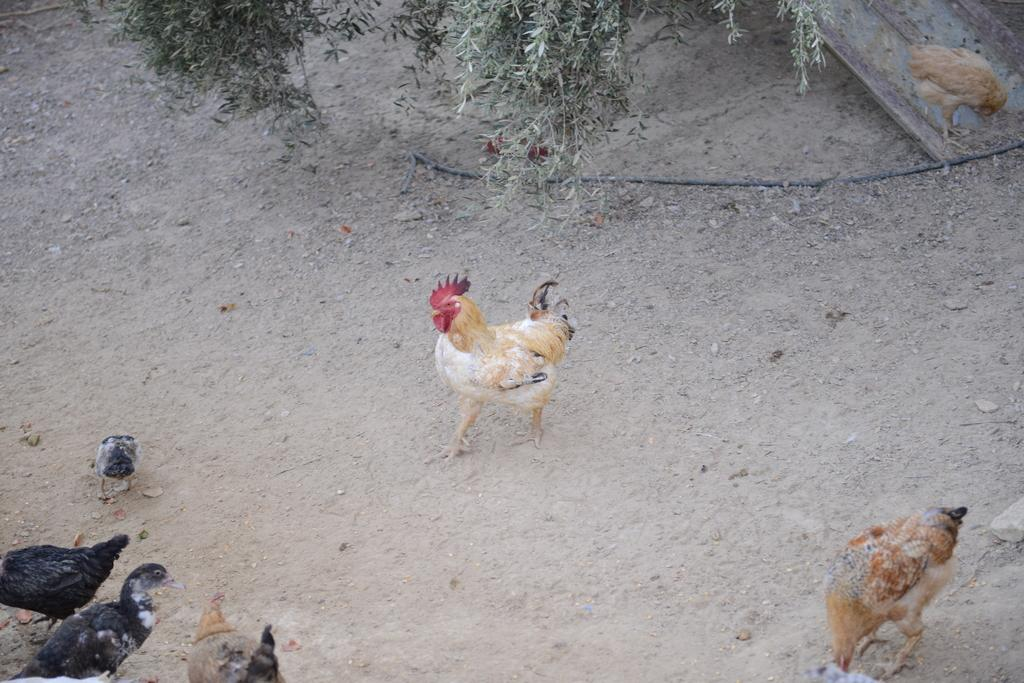What type of animals are at the bottom of the image? There are hens at the bottom of the image. What is the main subject in the center of the image? There is a cock in the center of the image. What type of vegetation is at the top of the image? There are trees at the top of the image. How many clocks can be seen hanging from the trees at the top of the image? There are no clocks present in the image; it features hens, a cock, and trees. What type of knee injury is visible on the cock in the center of the image? There is no knee injury visible on the cock in the image; it is a healthy bird. 